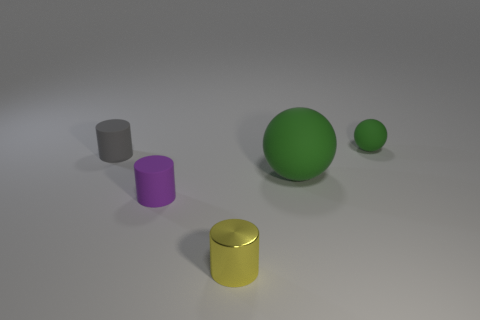Are there the same number of small objects on the right side of the tiny gray matte object and gray cylinders on the right side of the small ball?
Your response must be concise. No. There is a green thing behind the large green rubber object; does it have the same shape as the small rubber object that is in front of the large sphere?
Give a very brief answer. No. Is there anything else that has the same shape as the yellow shiny thing?
Offer a very short reply. Yes. There is a small purple thing that is made of the same material as the tiny sphere; what shape is it?
Provide a succinct answer. Cylinder. Are there the same number of large rubber spheres that are right of the tiny green rubber ball and small matte things?
Keep it short and to the point. No. Are the ball that is in front of the small gray cylinder and the small object that is on the right side of the yellow metallic cylinder made of the same material?
Your answer should be very brief. Yes. What is the shape of the green object that is on the left side of the tiny object that is behind the gray cylinder?
Keep it short and to the point. Sphere. There is a big ball that is the same material as the small purple cylinder; what is its color?
Provide a short and direct response. Green. Is the big thing the same color as the tiny metal thing?
Your answer should be very brief. No. There is a gray object that is the same size as the yellow shiny cylinder; what is its shape?
Ensure brevity in your answer.  Cylinder. 